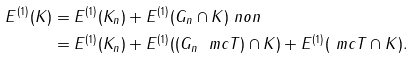<formula> <loc_0><loc_0><loc_500><loc_500>E ^ { ( 1 ) } ( K ) & = E ^ { ( 1 ) } ( K _ { n } ) + E ^ { ( 1 ) } ( G _ { n } \cap K ) \ n o n \\ & = E ^ { ( 1 ) } ( K _ { n } ) + E ^ { ( 1 ) } ( ( G _ { n } \ \ m c T ) \cap K ) + E ^ { ( 1 ) } ( \ m c T \cap K ) .</formula> 